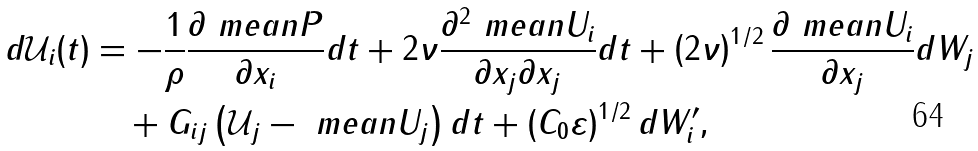Convert formula to latex. <formula><loc_0><loc_0><loc_500><loc_500>d \mathcal { U } _ { i } ( t ) & = - \frac { 1 } { \rho } \frac { \partial \ m e a n { P } } { \partial x _ { i } } d t + 2 \nu \frac { \partial ^ { 2 } \ m e a n { U _ { i } } } { \partial x _ { j } \partial x _ { j } } d t + \left ( 2 \nu \right ) ^ { 1 / 2 } \frac { \partial \ m e a n { U _ { i } } } { \partial x _ { j } } d W _ { j } \\ & \quad + G _ { i j } \left ( \mathcal { U } _ { j } - \ m e a n { U _ { j } } \right ) d t + \left ( C _ { 0 } \varepsilon \right ) ^ { 1 / 2 } d W ^ { \prime } _ { i } ,</formula> 